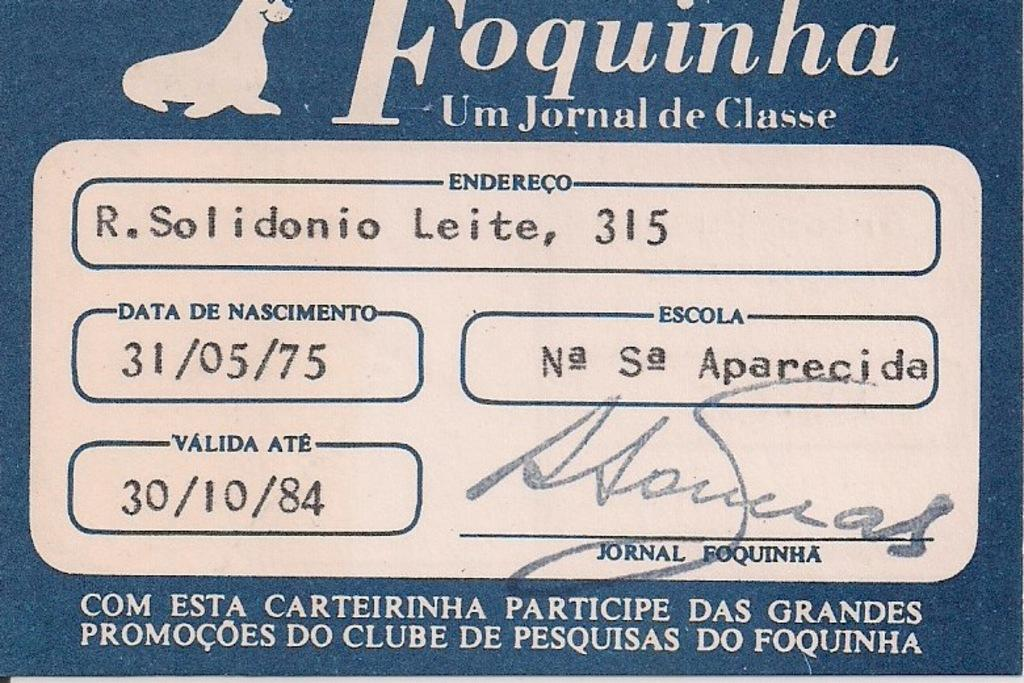What is featured on the poster in the image? The poster contains a picture of a seal. What else can be found on the poster besides the image? There is text and numbers on the poster. Is there any indication of authorship or ownership on the poster? Yes, there is a signature on the poster. What type of glue is used to hold the poster to the wall in the image? There is no information about glue or how the poster is attached to the wall in the image. Is there a hospital visible in the image? No, there is no hospital present in the image. --- Facts: 1. There is a car in the image. 2. The car is red. 3. The car has four wheels. 4. There is a person sitting in the driver's seat. 5. The person is wearing a hat. Absurd Topics: parrot, ocean, dance Conversation: What is the color of the car in the image? The car is red. How many wheels does the car have? The car has four wheels. Who is in the car? There is a person sitting in the driver's seat. What is the person wearing? The person is wearing a hat. Reasoning: Let's think step by step in order to produce the conversation. We start by identifying the main subject of the image, which is the car. Then, we describe its color and the number of wheels it has. Next, we mention the presence of a person in the car and describe what they are wearing. Each question is designed to elicit a specific detail about the image that is known from the provided facts. Absurd Question/Answer: Can you see a parrot sitting on the car's roof in the image? No, there is no parrot present in the image. Is the car driving along the ocean in the image? No, there is no ocean visible in the image. 